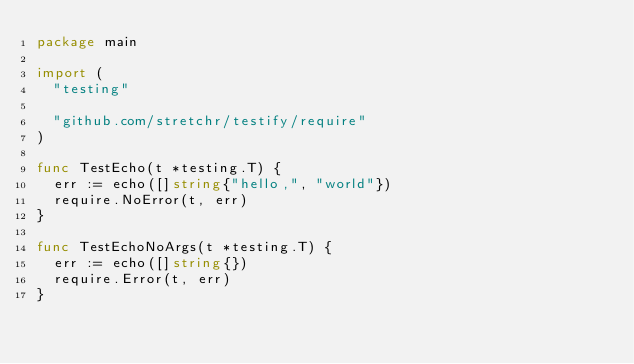<code> <loc_0><loc_0><loc_500><loc_500><_Go_>package main

import (
	"testing"

	"github.com/stretchr/testify/require"
)

func TestEcho(t *testing.T) {
	err := echo([]string{"hello,", "world"})
	require.NoError(t, err)
}

func TestEchoNoArgs(t *testing.T) {
	err := echo([]string{})
	require.Error(t, err)
}
</code> 